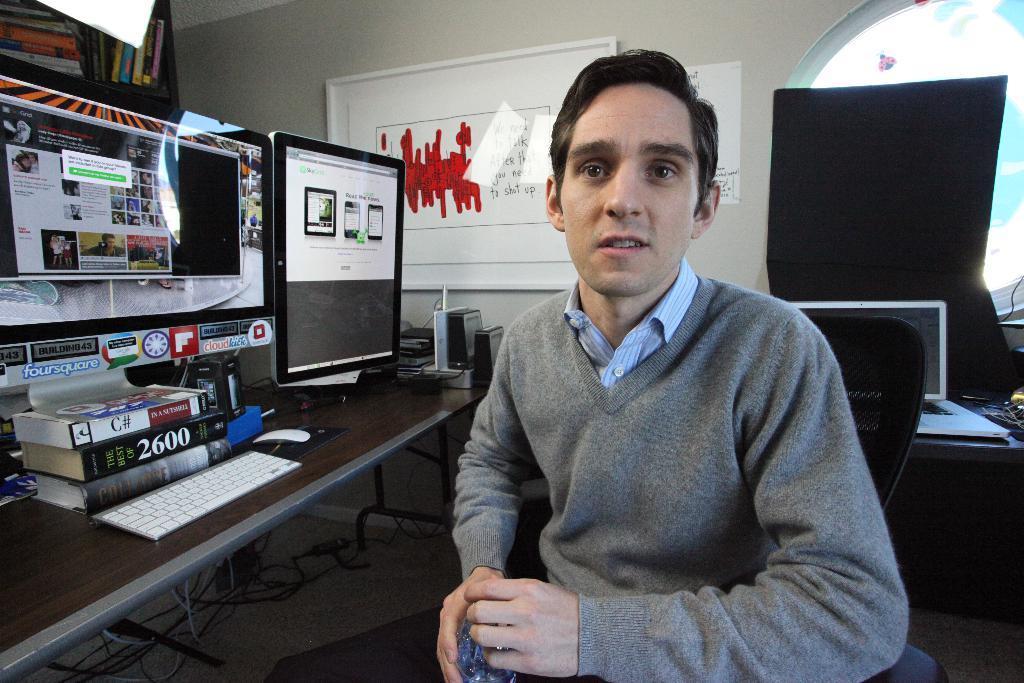How would you summarize this image in a sentence or two? In the image we can see a man wearing clothes and holding an object in hand. The man is sitting on the chair, we can see there are many systems and book. Here we can see a keyboard and a mouse. There are cable wires and a whiteboard. There is a shelf, in the shelf, we can see there are books kept. This is a wall and a window. 